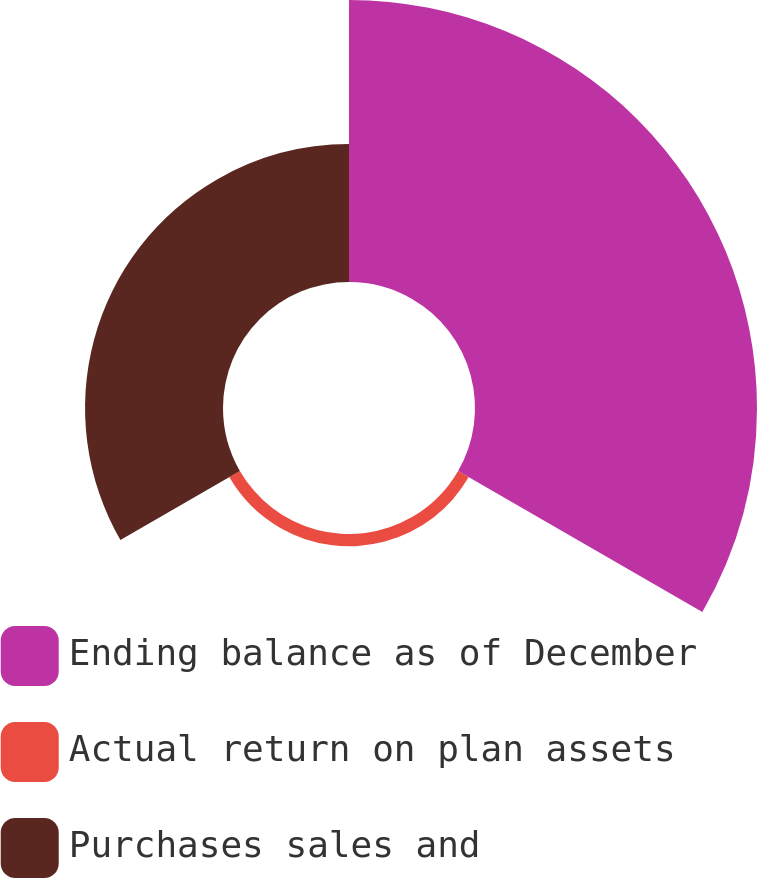<chart> <loc_0><loc_0><loc_500><loc_500><pie_chart><fcel>Ending balance as of December<fcel>Actual return on plan assets<fcel>Purchases sales and<nl><fcel>65.25%<fcel>2.83%<fcel>31.92%<nl></chart> 